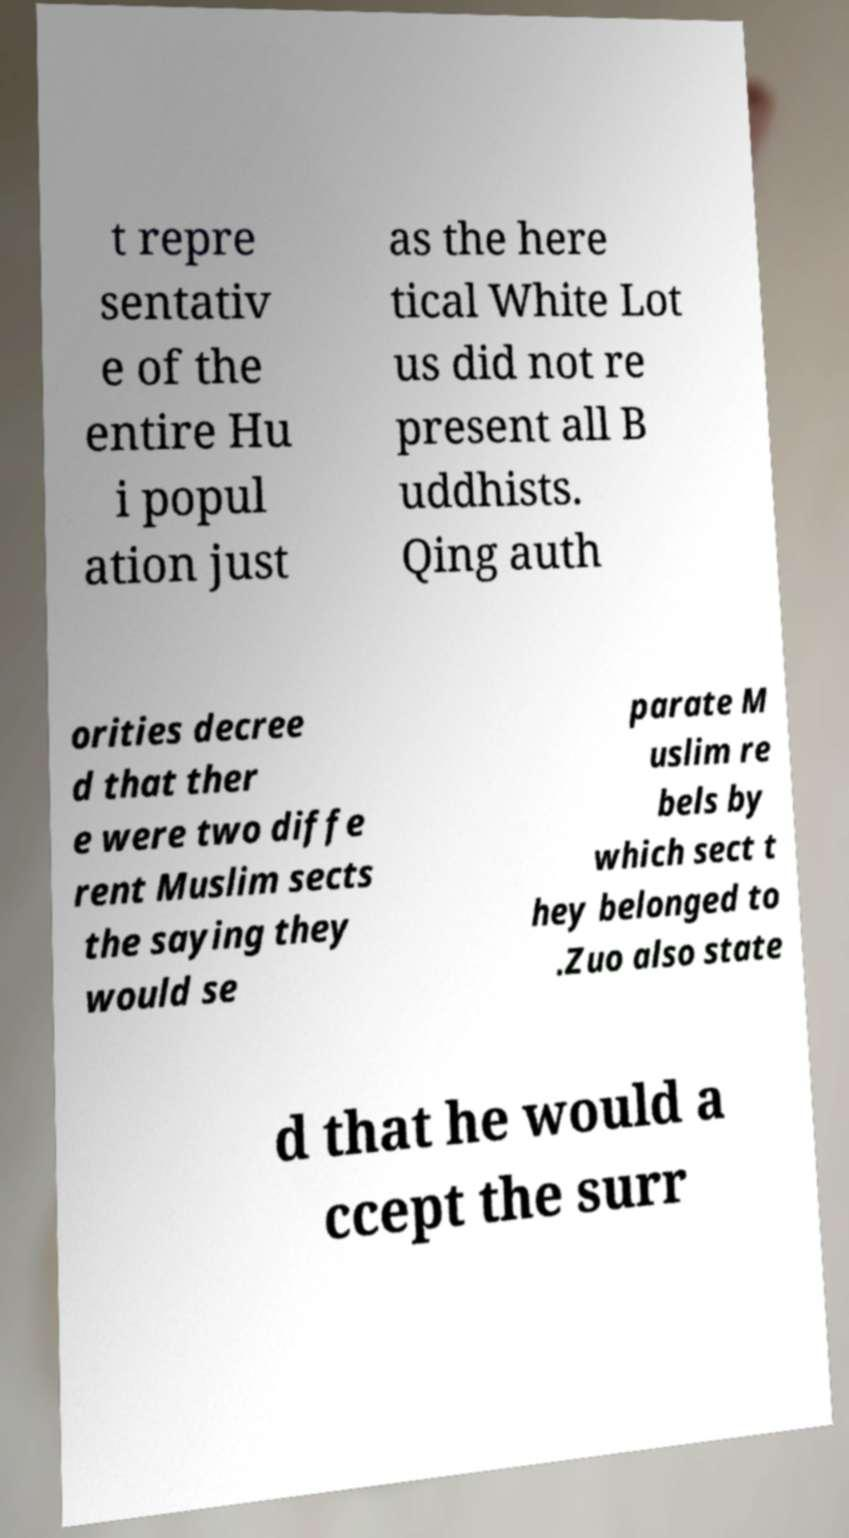There's text embedded in this image that I need extracted. Can you transcribe it verbatim? t repre sentativ e of the entire Hu i popul ation just as the here tical White Lot us did not re present all B uddhists. Qing auth orities decree d that ther e were two diffe rent Muslim sects the saying they would se parate M uslim re bels by which sect t hey belonged to .Zuo also state d that he would a ccept the surr 